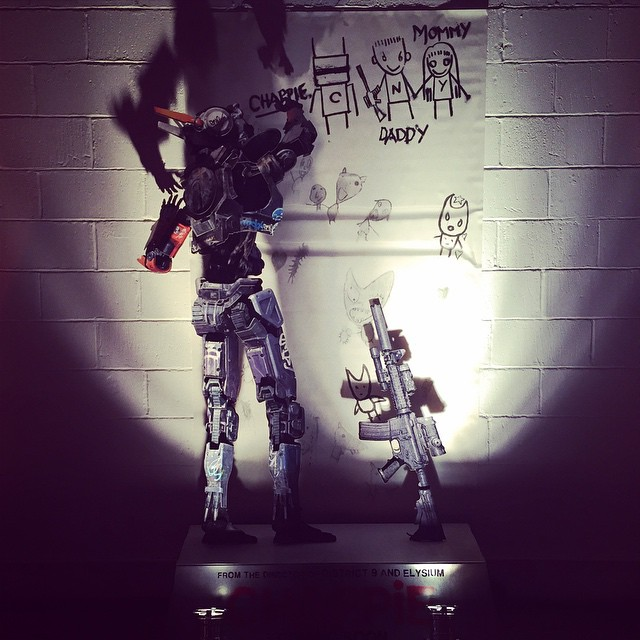If this robot could speak, what message might it convey to the children who drew these pictures? If the robot could speak, it might convey a message of protection and companionship to the children who drew these pictures. It could say, 'I am here to protect you and keep you safe. Your world of imagination and innocence is important, and I am part of it to ensure you can create, play, and grow without fear.' This type of message would reinforce the emotional connection between the mechanical entity and the human children, underscoring its role not just as a protector but as a comforting presence in their lives. 